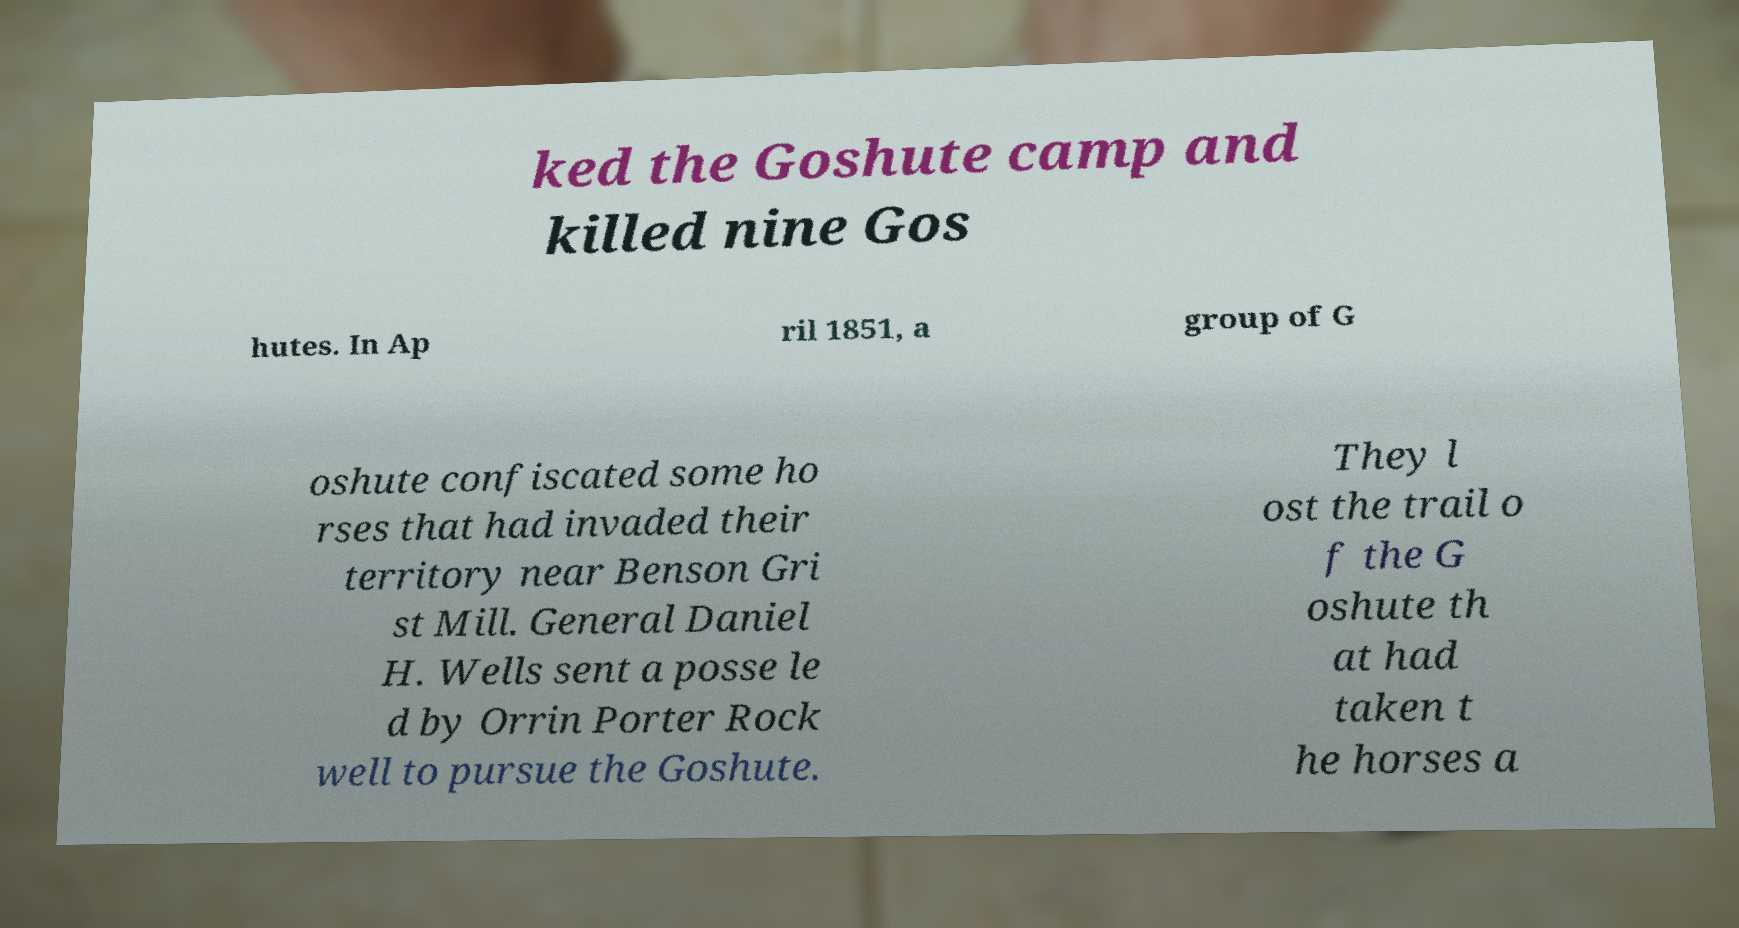Could you assist in decoding the text presented in this image and type it out clearly? ked the Goshute camp and killed nine Gos hutes. In Ap ril 1851, a group of G oshute confiscated some ho rses that had invaded their territory near Benson Gri st Mill. General Daniel H. Wells sent a posse le d by Orrin Porter Rock well to pursue the Goshute. They l ost the trail o f the G oshute th at had taken t he horses a 